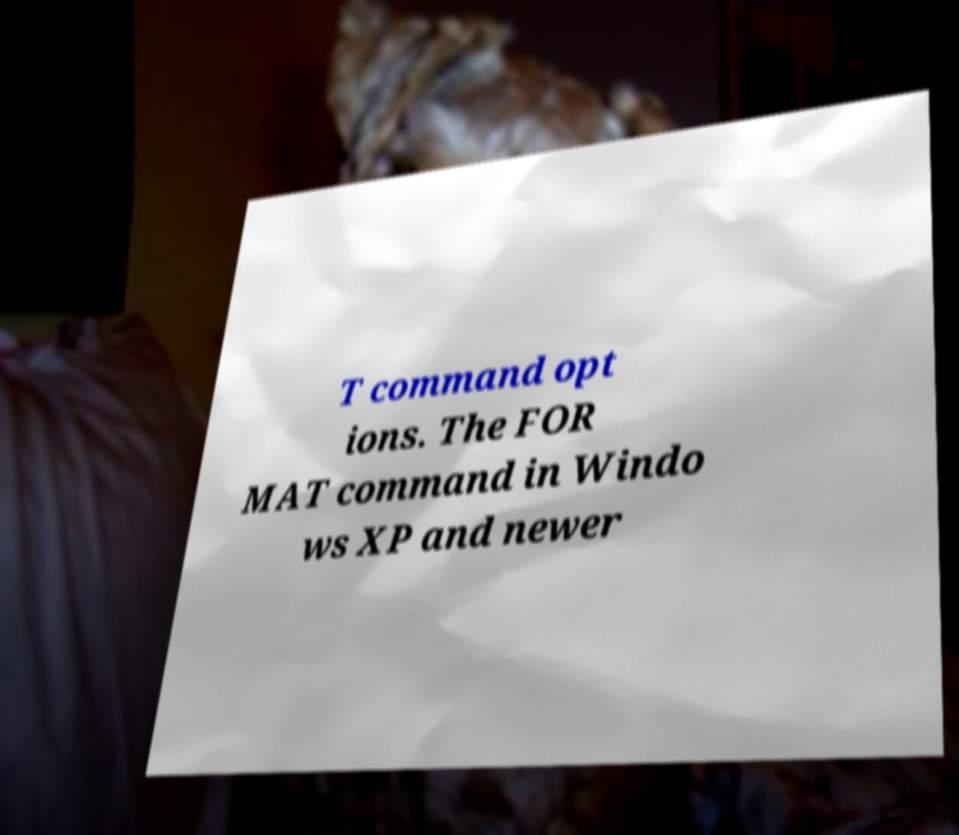Can you read and provide the text displayed in the image?This photo seems to have some interesting text. Can you extract and type it out for me? T command opt ions. The FOR MAT command in Windo ws XP and newer 